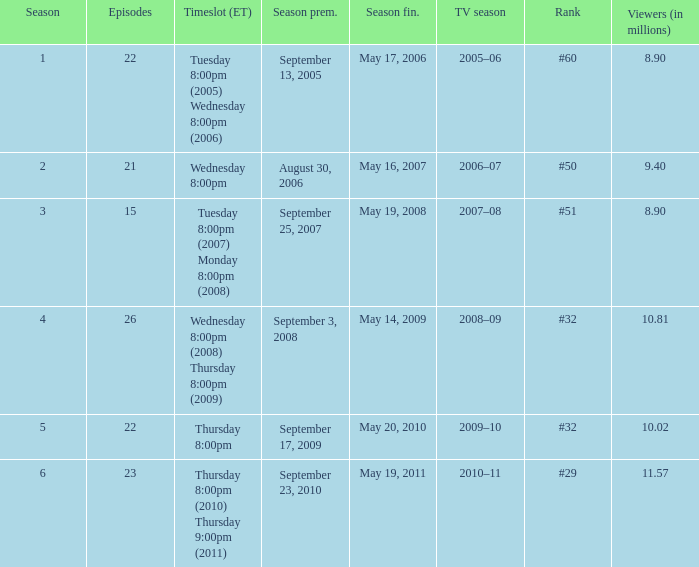How many seasons was the rank equal to #50? 1.0. 